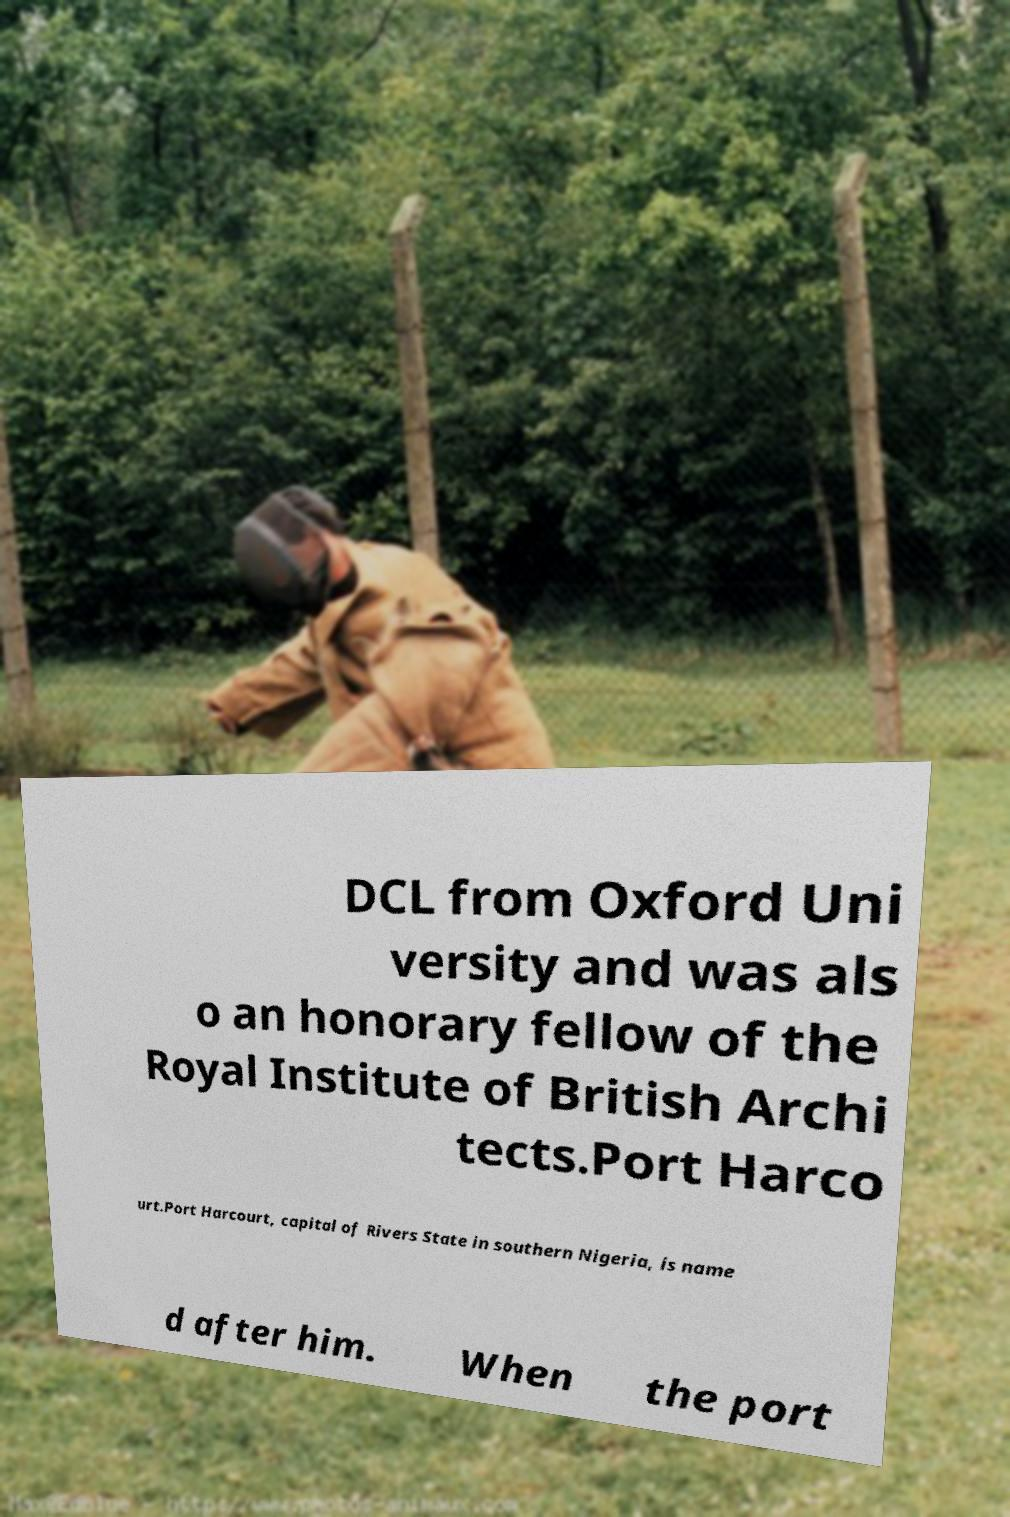Could you assist in decoding the text presented in this image and type it out clearly? DCL from Oxford Uni versity and was als o an honorary fellow of the Royal Institute of British Archi tects.Port Harco urt.Port Harcourt, capital of Rivers State in southern Nigeria, is name d after him. When the port 